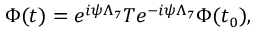<formula> <loc_0><loc_0><loc_500><loc_500>\Phi ( t ) = e ^ { i \psi \Lambda _ { 7 } } T e ^ { - i \psi \Lambda _ { 7 } } \Phi ( t _ { 0 } ) ,</formula> 